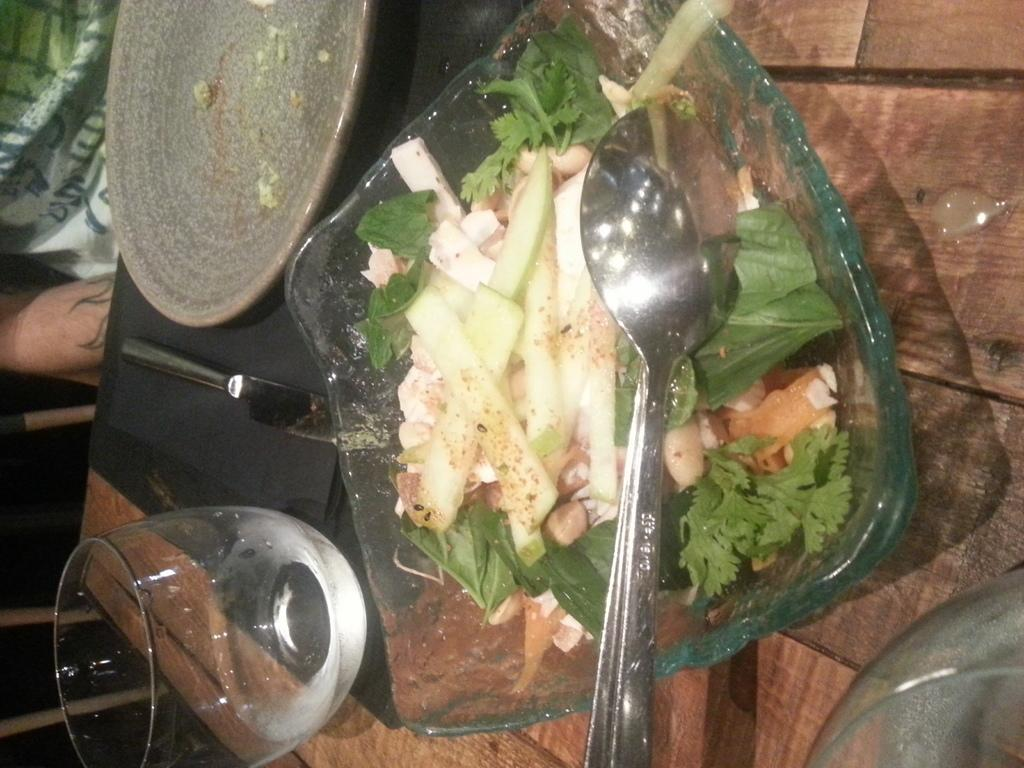What piece of furniture is present in the image? There is a table in the image. What items are on the table? There is a plate, a glass, a spoon, a bowl, and food on the table. Who is present in the image? There is a person in the image. How many legs does the grandfather have in the image? There is no mention of a grandfather in the image, and therefore no legs can be counted. 